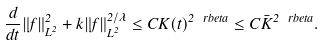<formula> <loc_0><loc_0><loc_500><loc_500>\frac { d } { d t } \| f \| ^ { 2 } _ { L ^ { 2 } } + k \| f \| ^ { 2 / \lambda } _ { L ^ { 2 } } \leq C K ( t ) ^ { 2 \ r b e t a } \leq C \bar { K } ^ { 2 \ r b e t a } .</formula> 